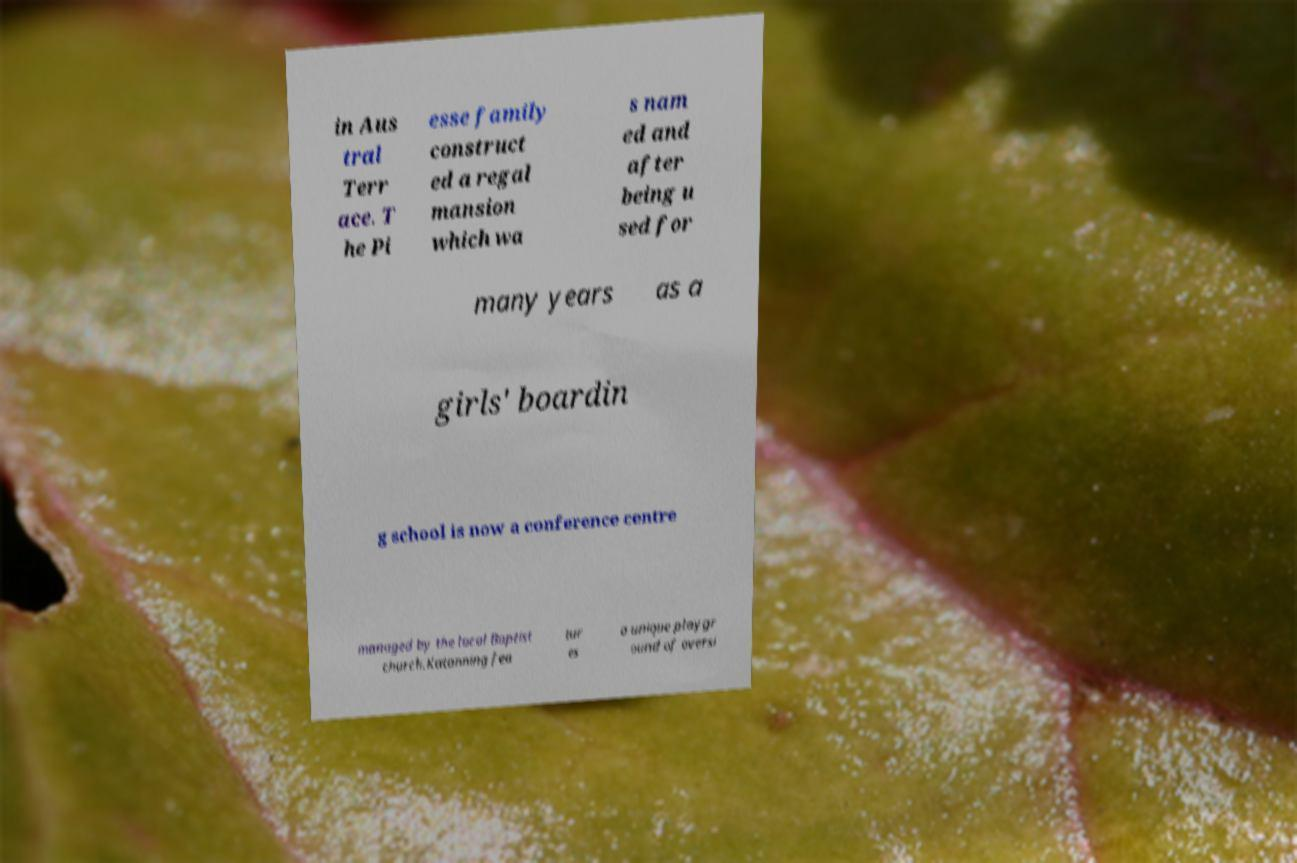What messages or text are displayed in this image? I need them in a readable, typed format. in Aus tral Terr ace. T he Pi esse family construct ed a regal mansion which wa s nam ed and after being u sed for many years as a girls' boardin g school is now a conference centre managed by the local Baptist church.Katanning fea tur es a unique playgr ound of oversi 